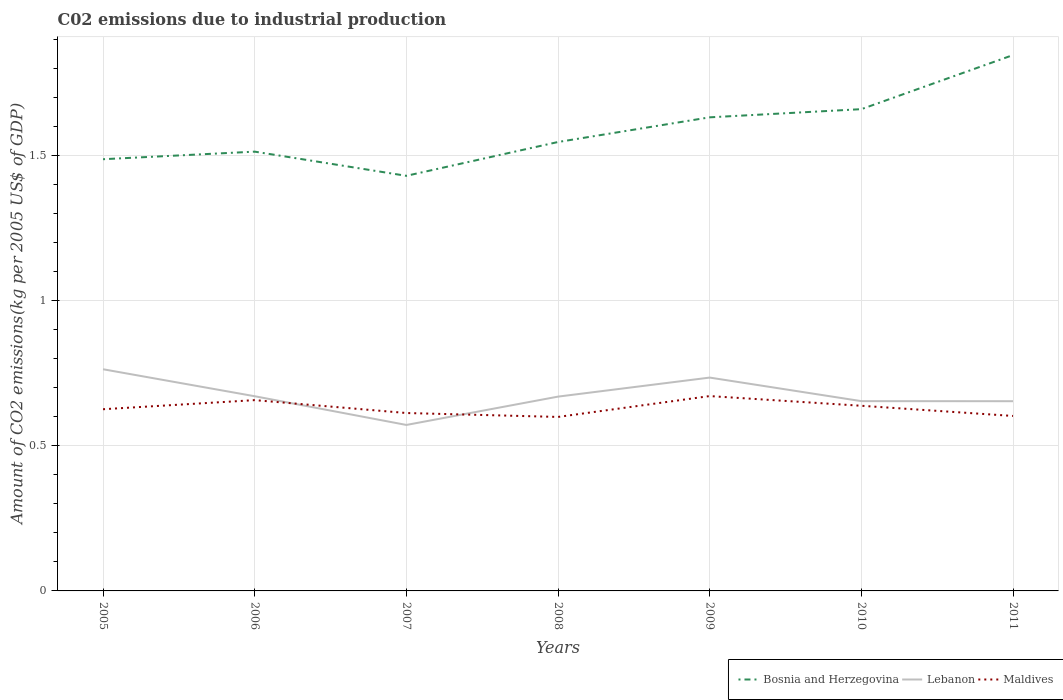Across all years, what is the maximum amount of CO2 emitted due to industrial production in Lebanon?
Give a very brief answer. 0.57. What is the total amount of CO2 emitted due to industrial production in Maldives in the graph?
Your response must be concise. 0.02. What is the difference between the highest and the second highest amount of CO2 emitted due to industrial production in Bosnia and Herzegovina?
Provide a short and direct response. 0.42. What is the difference between the highest and the lowest amount of CO2 emitted due to industrial production in Maldives?
Make the answer very short. 3. Is the amount of CO2 emitted due to industrial production in Bosnia and Herzegovina strictly greater than the amount of CO2 emitted due to industrial production in Maldives over the years?
Provide a succinct answer. No. How many lines are there?
Make the answer very short. 3. What is the difference between two consecutive major ticks on the Y-axis?
Offer a very short reply. 0.5. Are the values on the major ticks of Y-axis written in scientific E-notation?
Provide a succinct answer. No. How many legend labels are there?
Provide a succinct answer. 3. What is the title of the graph?
Your answer should be very brief. C02 emissions due to industrial production. Does "Sri Lanka" appear as one of the legend labels in the graph?
Offer a very short reply. No. What is the label or title of the Y-axis?
Offer a very short reply. Amount of CO2 emissions(kg per 2005 US$ of GDP). What is the Amount of CO2 emissions(kg per 2005 US$ of GDP) of Bosnia and Herzegovina in 2005?
Keep it short and to the point. 1.49. What is the Amount of CO2 emissions(kg per 2005 US$ of GDP) of Lebanon in 2005?
Give a very brief answer. 0.76. What is the Amount of CO2 emissions(kg per 2005 US$ of GDP) in Maldives in 2005?
Keep it short and to the point. 0.63. What is the Amount of CO2 emissions(kg per 2005 US$ of GDP) of Bosnia and Herzegovina in 2006?
Your answer should be compact. 1.51. What is the Amount of CO2 emissions(kg per 2005 US$ of GDP) of Lebanon in 2006?
Make the answer very short. 0.67. What is the Amount of CO2 emissions(kg per 2005 US$ of GDP) in Maldives in 2006?
Give a very brief answer. 0.66. What is the Amount of CO2 emissions(kg per 2005 US$ of GDP) in Bosnia and Herzegovina in 2007?
Offer a very short reply. 1.43. What is the Amount of CO2 emissions(kg per 2005 US$ of GDP) of Lebanon in 2007?
Keep it short and to the point. 0.57. What is the Amount of CO2 emissions(kg per 2005 US$ of GDP) in Maldives in 2007?
Make the answer very short. 0.61. What is the Amount of CO2 emissions(kg per 2005 US$ of GDP) in Bosnia and Herzegovina in 2008?
Give a very brief answer. 1.55. What is the Amount of CO2 emissions(kg per 2005 US$ of GDP) of Lebanon in 2008?
Give a very brief answer. 0.67. What is the Amount of CO2 emissions(kg per 2005 US$ of GDP) in Maldives in 2008?
Make the answer very short. 0.6. What is the Amount of CO2 emissions(kg per 2005 US$ of GDP) in Bosnia and Herzegovina in 2009?
Your answer should be very brief. 1.63. What is the Amount of CO2 emissions(kg per 2005 US$ of GDP) in Lebanon in 2009?
Offer a very short reply. 0.73. What is the Amount of CO2 emissions(kg per 2005 US$ of GDP) in Maldives in 2009?
Offer a very short reply. 0.67. What is the Amount of CO2 emissions(kg per 2005 US$ of GDP) in Bosnia and Herzegovina in 2010?
Make the answer very short. 1.66. What is the Amount of CO2 emissions(kg per 2005 US$ of GDP) of Lebanon in 2010?
Offer a very short reply. 0.65. What is the Amount of CO2 emissions(kg per 2005 US$ of GDP) in Maldives in 2010?
Provide a short and direct response. 0.64. What is the Amount of CO2 emissions(kg per 2005 US$ of GDP) of Bosnia and Herzegovina in 2011?
Provide a short and direct response. 1.84. What is the Amount of CO2 emissions(kg per 2005 US$ of GDP) in Lebanon in 2011?
Ensure brevity in your answer.  0.65. What is the Amount of CO2 emissions(kg per 2005 US$ of GDP) in Maldives in 2011?
Make the answer very short. 0.6. Across all years, what is the maximum Amount of CO2 emissions(kg per 2005 US$ of GDP) of Bosnia and Herzegovina?
Ensure brevity in your answer.  1.84. Across all years, what is the maximum Amount of CO2 emissions(kg per 2005 US$ of GDP) of Lebanon?
Provide a succinct answer. 0.76. Across all years, what is the maximum Amount of CO2 emissions(kg per 2005 US$ of GDP) in Maldives?
Provide a succinct answer. 0.67. Across all years, what is the minimum Amount of CO2 emissions(kg per 2005 US$ of GDP) in Bosnia and Herzegovina?
Offer a very short reply. 1.43. Across all years, what is the minimum Amount of CO2 emissions(kg per 2005 US$ of GDP) of Lebanon?
Your response must be concise. 0.57. Across all years, what is the minimum Amount of CO2 emissions(kg per 2005 US$ of GDP) in Maldives?
Your answer should be very brief. 0.6. What is the total Amount of CO2 emissions(kg per 2005 US$ of GDP) in Bosnia and Herzegovina in the graph?
Offer a terse response. 11.11. What is the total Amount of CO2 emissions(kg per 2005 US$ of GDP) in Lebanon in the graph?
Provide a succinct answer. 4.71. What is the total Amount of CO2 emissions(kg per 2005 US$ of GDP) of Maldives in the graph?
Your answer should be compact. 4.4. What is the difference between the Amount of CO2 emissions(kg per 2005 US$ of GDP) of Bosnia and Herzegovina in 2005 and that in 2006?
Provide a short and direct response. -0.03. What is the difference between the Amount of CO2 emissions(kg per 2005 US$ of GDP) in Lebanon in 2005 and that in 2006?
Ensure brevity in your answer.  0.09. What is the difference between the Amount of CO2 emissions(kg per 2005 US$ of GDP) in Maldives in 2005 and that in 2006?
Provide a succinct answer. -0.03. What is the difference between the Amount of CO2 emissions(kg per 2005 US$ of GDP) of Bosnia and Herzegovina in 2005 and that in 2007?
Make the answer very short. 0.06. What is the difference between the Amount of CO2 emissions(kg per 2005 US$ of GDP) of Lebanon in 2005 and that in 2007?
Your answer should be compact. 0.19. What is the difference between the Amount of CO2 emissions(kg per 2005 US$ of GDP) in Maldives in 2005 and that in 2007?
Make the answer very short. 0.01. What is the difference between the Amount of CO2 emissions(kg per 2005 US$ of GDP) in Bosnia and Herzegovina in 2005 and that in 2008?
Offer a very short reply. -0.06. What is the difference between the Amount of CO2 emissions(kg per 2005 US$ of GDP) in Lebanon in 2005 and that in 2008?
Ensure brevity in your answer.  0.09. What is the difference between the Amount of CO2 emissions(kg per 2005 US$ of GDP) in Maldives in 2005 and that in 2008?
Keep it short and to the point. 0.03. What is the difference between the Amount of CO2 emissions(kg per 2005 US$ of GDP) in Bosnia and Herzegovina in 2005 and that in 2009?
Keep it short and to the point. -0.14. What is the difference between the Amount of CO2 emissions(kg per 2005 US$ of GDP) of Lebanon in 2005 and that in 2009?
Ensure brevity in your answer.  0.03. What is the difference between the Amount of CO2 emissions(kg per 2005 US$ of GDP) in Maldives in 2005 and that in 2009?
Provide a succinct answer. -0.05. What is the difference between the Amount of CO2 emissions(kg per 2005 US$ of GDP) of Bosnia and Herzegovina in 2005 and that in 2010?
Your answer should be compact. -0.17. What is the difference between the Amount of CO2 emissions(kg per 2005 US$ of GDP) of Lebanon in 2005 and that in 2010?
Make the answer very short. 0.11. What is the difference between the Amount of CO2 emissions(kg per 2005 US$ of GDP) in Maldives in 2005 and that in 2010?
Provide a succinct answer. -0.01. What is the difference between the Amount of CO2 emissions(kg per 2005 US$ of GDP) in Bosnia and Herzegovina in 2005 and that in 2011?
Your answer should be compact. -0.36. What is the difference between the Amount of CO2 emissions(kg per 2005 US$ of GDP) of Lebanon in 2005 and that in 2011?
Ensure brevity in your answer.  0.11. What is the difference between the Amount of CO2 emissions(kg per 2005 US$ of GDP) of Maldives in 2005 and that in 2011?
Provide a succinct answer. 0.02. What is the difference between the Amount of CO2 emissions(kg per 2005 US$ of GDP) in Bosnia and Herzegovina in 2006 and that in 2007?
Make the answer very short. 0.08. What is the difference between the Amount of CO2 emissions(kg per 2005 US$ of GDP) of Lebanon in 2006 and that in 2007?
Your answer should be compact. 0.1. What is the difference between the Amount of CO2 emissions(kg per 2005 US$ of GDP) of Maldives in 2006 and that in 2007?
Make the answer very short. 0.04. What is the difference between the Amount of CO2 emissions(kg per 2005 US$ of GDP) in Bosnia and Herzegovina in 2006 and that in 2008?
Ensure brevity in your answer.  -0.03. What is the difference between the Amount of CO2 emissions(kg per 2005 US$ of GDP) of Lebanon in 2006 and that in 2008?
Ensure brevity in your answer.  0. What is the difference between the Amount of CO2 emissions(kg per 2005 US$ of GDP) in Maldives in 2006 and that in 2008?
Provide a succinct answer. 0.06. What is the difference between the Amount of CO2 emissions(kg per 2005 US$ of GDP) of Bosnia and Herzegovina in 2006 and that in 2009?
Ensure brevity in your answer.  -0.12. What is the difference between the Amount of CO2 emissions(kg per 2005 US$ of GDP) in Lebanon in 2006 and that in 2009?
Ensure brevity in your answer.  -0.06. What is the difference between the Amount of CO2 emissions(kg per 2005 US$ of GDP) of Maldives in 2006 and that in 2009?
Provide a succinct answer. -0.01. What is the difference between the Amount of CO2 emissions(kg per 2005 US$ of GDP) in Bosnia and Herzegovina in 2006 and that in 2010?
Provide a succinct answer. -0.15. What is the difference between the Amount of CO2 emissions(kg per 2005 US$ of GDP) in Lebanon in 2006 and that in 2010?
Offer a very short reply. 0.02. What is the difference between the Amount of CO2 emissions(kg per 2005 US$ of GDP) of Maldives in 2006 and that in 2010?
Offer a terse response. 0.02. What is the difference between the Amount of CO2 emissions(kg per 2005 US$ of GDP) of Bosnia and Herzegovina in 2006 and that in 2011?
Offer a very short reply. -0.33. What is the difference between the Amount of CO2 emissions(kg per 2005 US$ of GDP) of Lebanon in 2006 and that in 2011?
Keep it short and to the point. 0.02. What is the difference between the Amount of CO2 emissions(kg per 2005 US$ of GDP) in Maldives in 2006 and that in 2011?
Your answer should be compact. 0.05. What is the difference between the Amount of CO2 emissions(kg per 2005 US$ of GDP) of Bosnia and Herzegovina in 2007 and that in 2008?
Provide a succinct answer. -0.12. What is the difference between the Amount of CO2 emissions(kg per 2005 US$ of GDP) in Lebanon in 2007 and that in 2008?
Your answer should be compact. -0.1. What is the difference between the Amount of CO2 emissions(kg per 2005 US$ of GDP) in Maldives in 2007 and that in 2008?
Your answer should be compact. 0.01. What is the difference between the Amount of CO2 emissions(kg per 2005 US$ of GDP) of Bosnia and Herzegovina in 2007 and that in 2009?
Offer a very short reply. -0.2. What is the difference between the Amount of CO2 emissions(kg per 2005 US$ of GDP) of Lebanon in 2007 and that in 2009?
Offer a very short reply. -0.16. What is the difference between the Amount of CO2 emissions(kg per 2005 US$ of GDP) in Maldives in 2007 and that in 2009?
Ensure brevity in your answer.  -0.06. What is the difference between the Amount of CO2 emissions(kg per 2005 US$ of GDP) of Bosnia and Herzegovina in 2007 and that in 2010?
Offer a very short reply. -0.23. What is the difference between the Amount of CO2 emissions(kg per 2005 US$ of GDP) of Lebanon in 2007 and that in 2010?
Provide a short and direct response. -0.08. What is the difference between the Amount of CO2 emissions(kg per 2005 US$ of GDP) of Maldives in 2007 and that in 2010?
Your answer should be compact. -0.02. What is the difference between the Amount of CO2 emissions(kg per 2005 US$ of GDP) of Bosnia and Herzegovina in 2007 and that in 2011?
Keep it short and to the point. -0.42. What is the difference between the Amount of CO2 emissions(kg per 2005 US$ of GDP) in Lebanon in 2007 and that in 2011?
Your answer should be very brief. -0.08. What is the difference between the Amount of CO2 emissions(kg per 2005 US$ of GDP) in Maldives in 2007 and that in 2011?
Provide a succinct answer. 0.01. What is the difference between the Amount of CO2 emissions(kg per 2005 US$ of GDP) in Bosnia and Herzegovina in 2008 and that in 2009?
Your response must be concise. -0.09. What is the difference between the Amount of CO2 emissions(kg per 2005 US$ of GDP) of Lebanon in 2008 and that in 2009?
Ensure brevity in your answer.  -0.07. What is the difference between the Amount of CO2 emissions(kg per 2005 US$ of GDP) of Maldives in 2008 and that in 2009?
Make the answer very short. -0.07. What is the difference between the Amount of CO2 emissions(kg per 2005 US$ of GDP) of Bosnia and Herzegovina in 2008 and that in 2010?
Provide a short and direct response. -0.11. What is the difference between the Amount of CO2 emissions(kg per 2005 US$ of GDP) of Lebanon in 2008 and that in 2010?
Offer a terse response. 0.02. What is the difference between the Amount of CO2 emissions(kg per 2005 US$ of GDP) of Maldives in 2008 and that in 2010?
Provide a succinct answer. -0.04. What is the difference between the Amount of CO2 emissions(kg per 2005 US$ of GDP) of Bosnia and Herzegovina in 2008 and that in 2011?
Your answer should be compact. -0.3. What is the difference between the Amount of CO2 emissions(kg per 2005 US$ of GDP) of Lebanon in 2008 and that in 2011?
Offer a terse response. 0.02. What is the difference between the Amount of CO2 emissions(kg per 2005 US$ of GDP) in Maldives in 2008 and that in 2011?
Offer a very short reply. -0. What is the difference between the Amount of CO2 emissions(kg per 2005 US$ of GDP) in Bosnia and Herzegovina in 2009 and that in 2010?
Ensure brevity in your answer.  -0.03. What is the difference between the Amount of CO2 emissions(kg per 2005 US$ of GDP) of Lebanon in 2009 and that in 2010?
Keep it short and to the point. 0.08. What is the difference between the Amount of CO2 emissions(kg per 2005 US$ of GDP) in Maldives in 2009 and that in 2010?
Offer a very short reply. 0.03. What is the difference between the Amount of CO2 emissions(kg per 2005 US$ of GDP) in Bosnia and Herzegovina in 2009 and that in 2011?
Provide a short and direct response. -0.21. What is the difference between the Amount of CO2 emissions(kg per 2005 US$ of GDP) of Lebanon in 2009 and that in 2011?
Offer a very short reply. 0.08. What is the difference between the Amount of CO2 emissions(kg per 2005 US$ of GDP) of Maldives in 2009 and that in 2011?
Offer a terse response. 0.07. What is the difference between the Amount of CO2 emissions(kg per 2005 US$ of GDP) of Bosnia and Herzegovina in 2010 and that in 2011?
Your response must be concise. -0.19. What is the difference between the Amount of CO2 emissions(kg per 2005 US$ of GDP) of Lebanon in 2010 and that in 2011?
Provide a succinct answer. 0. What is the difference between the Amount of CO2 emissions(kg per 2005 US$ of GDP) of Maldives in 2010 and that in 2011?
Your answer should be very brief. 0.04. What is the difference between the Amount of CO2 emissions(kg per 2005 US$ of GDP) in Bosnia and Herzegovina in 2005 and the Amount of CO2 emissions(kg per 2005 US$ of GDP) in Lebanon in 2006?
Offer a very short reply. 0.82. What is the difference between the Amount of CO2 emissions(kg per 2005 US$ of GDP) in Bosnia and Herzegovina in 2005 and the Amount of CO2 emissions(kg per 2005 US$ of GDP) in Maldives in 2006?
Provide a succinct answer. 0.83. What is the difference between the Amount of CO2 emissions(kg per 2005 US$ of GDP) of Lebanon in 2005 and the Amount of CO2 emissions(kg per 2005 US$ of GDP) of Maldives in 2006?
Your answer should be compact. 0.11. What is the difference between the Amount of CO2 emissions(kg per 2005 US$ of GDP) of Bosnia and Herzegovina in 2005 and the Amount of CO2 emissions(kg per 2005 US$ of GDP) of Lebanon in 2007?
Ensure brevity in your answer.  0.91. What is the difference between the Amount of CO2 emissions(kg per 2005 US$ of GDP) of Bosnia and Herzegovina in 2005 and the Amount of CO2 emissions(kg per 2005 US$ of GDP) of Maldives in 2007?
Your answer should be compact. 0.87. What is the difference between the Amount of CO2 emissions(kg per 2005 US$ of GDP) of Lebanon in 2005 and the Amount of CO2 emissions(kg per 2005 US$ of GDP) of Maldives in 2007?
Offer a very short reply. 0.15. What is the difference between the Amount of CO2 emissions(kg per 2005 US$ of GDP) in Bosnia and Herzegovina in 2005 and the Amount of CO2 emissions(kg per 2005 US$ of GDP) in Lebanon in 2008?
Make the answer very short. 0.82. What is the difference between the Amount of CO2 emissions(kg per 2005 US$ of GDP) in Bosnia and Herzegovina in 2005 and the Amount of CO2 emissions(kg per 2005 US$ of GDP) in Maldives in 2008?
Provide a succinct answer. 0.89. What is the difference between the Amount of CO2 emissions(kg per 2005 US$ of GDP) in Lebanon in 2005 and the Amount of CO2 emissions(kg per 2005 US$ of GDP) in Maldives in 2008?
Keep it short and to the point. 0.16. What is the difference between the Amount of CO2 emissions(kg per 2005 US$ of GDP) of Bosnia and Herzegovina in 2005 and the Amount of CO2 emissions(kg per 2005 US$ of GDP) of Lebanon in 2009?
Provide a short and direct response. 0.75. What is the difference between the Amount of CO2 emissions(kg per 2005 US$ of GDP) of Bosnia and Herzegovina in 2005 and the Amount of CO2 emissions(kg per 2005 US$ of GDP) of Maldives in 2009?
Your answer should be very brief. 0.82. What is the difference between the Amount of CO2 emissions(kg per 2005 US$ of GDP) of Lebanon in 2005 and the Amount of CO2 emissions(kg per 2005 US$ of GDP) of Maldives in 2009?
Ensure brevity in your answer.  0.09. What is the difference between the Amount of CO2 emissions(kg per 2005 US$ of GDP) in Bosnia and Herzegovina in 2005 and the Amount of CO2 emissions(kg per 2005 US$ of GDP) in Lebanon in 2010?
Keep it short and to the point. 0.83. What is the difference between the Amount of CO2 emissions(kg per 2005 US$ of GDP) of Bosnia and Herzegovina in 2005 and the Amount of CO2 emissions(kg per 2005 US$ of GDP) of Maldives in 2010?
Your answer should be compact. 0.85. What is the difference between the Amount of CO2 emissions(kg per 2005 US$ of GDP) in Lebanon in 2005 and the Amount of CO2 emissions(kg per 2005 US$ of GDP) in Maldives in 2010?
Provide a succinct answer. 0.13. What is the difference between the Amount of CO2 emissions(kg per 2005 US$ of GDP) of Bosnia and Herzegovina in 2005 and the Amount of CO2 emissions(kg per 2005 US$ of GDP) of Lebanon in 2011?
Provide a short and direct response. 0.83. What is the difference between the Amount of CO2 emissions(kg per 2005 US$ of GDP) of Bosnia and Herzegovina in 2005 and the Amount of CO2 emissions(kg per 2005 US$ of GDP) of Maldives in 2011?
Offer a terse response. 0.88. What is the difference between the Amount of CO2 emissions(kg per 2005 US$ of GDP) of Lebanon in 2005 and the Amount of CO2 emissions(kg per 2005 US$ of GDP) of Maldives in 2011?
Offer a very short reply. 0.16. What is the difference between the Amount of CO2 emissions(kg per 2005 US$ of GDP) of Bosnia and Herzegovina in 2006 and the Amount of CO2 emissions(kg per 2005 US$ of GDP) of Lebanon in 2007?
Provide a succinct answer. 0.94. What is the difference between the Amount of CO2 emissions(kg per 2005 US$ of GDP) of Bosnia and Herzegovina in 2006 and the Amount of CO2 emissions(kg per 2005 US$ of GDP) of Maldives in 2007?
Your answer should be very brief. 0.9. What is the difference between the Amount of CO2 emissions(kg per 2005 US$ of GDP) of Lebanon in 2006 and the Amount of CO2 emissions(kg per 2005 US$ of GDP) of Maldives in 2007?
Provide a succinct answer. 0.06. What is the difference between the Amount of CO2 emissions(kg per 2005 US$ of GDP) of Bosnia and Herzegovina in 2006 and the Amount of CO2 emissions(kg per 2005 US$ of GDP) of Lebanon in 2008?
Provide a short and direct response. 0.84. What is the difference between the Amount of CO2 emissions(kg per 2005 US$ of GDP) in Bosnia and Herzegovina in 2006 and the Amount of CO2 emissions(kg per 2005 US$ of GDP) in Maldives in 2008?
Make the answer very short. 0.91. What is the difference between the Amount of CO2 emissions(kg per 2005 US$ of GDP) in Lebanon in 2006 and the Amount of CO2 emissions(kg per 2005 US$ of GDP) in Maldives in 2008?
Provide a succinct answer. 0.07. What is the difference between the Amount of CO2 emissions(kg per 2005 US$ of GDP) in Bosnia and Herzegovina in 2006 and the Amount of CO2 emissions(kg per 2005 US$ of GDP) in Maldives in 2009?
Keep it short and to the point. 0.84. What is the difference between the Amount of CO2 emissions(kg per 2005 US$ of GDP) in Lebanon in 2006 and the Amount of CO2 emissions(kg per 2005 US$ of GDP) in Maldives in 2009?
Your response must be concise. -0. What is the difference between the Amount of CO2 emissions(kg per 2005 US$ of GDP) in Bosnia and Herzegovina in 2006 and the Amount of CO2 emissions(kg per 2005 US$ of GDP) in Lebanon in 2010?
Provide a short and direct response. 0.86. What is the difference between the Amount of CO2 emissions(kg per 2005 US$ of GDP) in Bosnia and Herzegovina in 2006 and the Amount of CO2 emissions(kg per 2005 US$ of GDP) in Maldives in 2010?
Provide a short and direct response. 0.87. What is the difference between the Amount of CO2 emissions(kg per 2005 US$ of GDP) of Lebanon in 2006 and the Amount of CO2 emissions(kg per 2005 US$ of GDP) of Maldives in 2010?
Your answer should be very brief. 0.03. What is the difference between the Amount of CO2 emissions(kg per 2005 US$ of GDP) of Bosnia and Herzegovina in 2006 and the Amount of CO2 emissions(kg per 2005 US$ of GDP) of Lebanon in 2011?
Your answer should be very brief. 0.86. What is the difference between the Amount of CO2 emissions(kg per 2005 US$ of GDP) in Bosnia and Herzegovina in 2006 and the Amount of CO2 emissions(kg per 2005 US$ of GDP) in Maldives in 2011?
Ensure brevity in your answer.  0.91. What is the difference between the Amount of CO2 emissions(kg per 2005 US$ of GDP) of Lebanon in 2006 and the Amount of CO2 emissions(kg per 2005 US$ of GDP) of Maldives in 2011?
Offer a terse response. 0.07. What is the difference between the Amount of CO2 emissions(kg per 2005 US$ of GDP) in Bosnia and Herzegovina in 2007 and the Amount of CO2 emissions(kg per 2005 US$ of GDP) in Lebanon in 2008?
Keep it short and to the point. 0.76. What is the difference between the Amount of CO2 emissions(kg per 2005 US$ of GDP) of Bosnia and Herzegovina in 2007 and the Amount of CO2 emissions(kg per 2005 US$ of GDP) of Maldives in 2008?
Ensure brevity in your answer.  0.83. What is the difference between the Amount of CO2 emissions(kg per 2005 US$ of GDP) in Lebanon in 2007 and the Amount of CO2 emissions(kg per 2005 US$ of GDP) in Maldives in 2008?
Keep it short and to the point. -0.03. What is the difference between the Amount of CO2 emissions(kg per 2005 US$ of GDP) of Bosnia and Herzegovina in 2007 and the Amount of CO2 emissions(kg per 2005 US$ of GDP) of Lebanon in 2009?
Offer a terse response. 0.69. What is the difference between the Amount of CO2 emissions(kg per 2005 US$ of GDP) of Bosnia and Herzegovina in 2007 and the Amount of CO2 emissions(kg per 2005 US$ of GDP) of Maldives in 2009?
Ensure brevity in your answer.  0.76. What is the difference between the Amount of CO2 emissions(kg per 2005 US$ of GDP) in Lebanon in 2007 and the Amount of CO2 emissions(kg per 2005 US$ of GDP) in Maldives in 2009?
Your answer should be very brief. -0.1. What is the difference between the Amount of CO2 emissions(kg per 2005 US$ of GDP) in Bosnia and Herzegovina in 2007 and the Amount of CO2 emissions(kg per 2005 US$ of GDP) in Lebanon in 2010?
Ensure brevity in your answer.  0.78. What is the difference between the Amount of CO2 emissions(kg per 2005 US$ of GDP) of Bosnia and Herzegovina in 2007 and the Amount of CO2 emissions(kg per 2005 US$ of GDP) of Maldives in 2010?
Ensure brevity in your answer.  0.79. What is the difference between the Amount of CO2 emissions(kg per 2005 US$ of GDP) in Lebanon in 2007 and the Amount of CO2 emissions(kg per 2005 US$ of GDP) in Maldives in 2010?
Offer a very short reply. -0.07. What is the difference between the Amount of CO2 emissions(kg per 2005 US$ of GDP) of Bosnia and Herzegovina in 2007 and the Amount of CO2 emissions(kg per 2005 US$ of GDP) of Lebanon in 2011?
Keep it short and to the point. 0.78. What is the difference between the Amount of CO2 emissions(kg per 2005 US$ of GDP) of Bosnia and Herzegovina in 2007 and the Amount of CO2 emissions(kg per 2005 US$ of GDP) of Maldives in 2011?
Ensure brevity in your answer.  0.83. What is the difference between the Amount of CO2 emissions(kg per 2005 US$ of GDP) of Lebanon in 2007 and the Amount of CO2 emissions(kg per 2005 US$ of GDP) of Maldives in 2011?
Your answer should be compact. -0.03. What is the difference between the Amount of CO2 emissions(kg per 2005 US$ of GDP) of Bosnia and Herzegovina in 2008 and the Amount of CO2 emissions(kg per 2005 US$ of GDP) of Lebanon in 2009?
Your answer should be compact. 0.81. What is the difference between the Amount of CO2 emissions(kg per 2005 US$ of GDP) of Bosnia and Herzegovina in 2008 and the Amount of CO2 emissions(kg per 2005 US$ of GDP) of Maldives in 2009?
Provide a succinct answer. 0.87. What is the difference between the Amount of CO2 emissions(kg per 2005 US$ of GDP) in Lebanon in 2008 and the Amount of CO2 emissions(kg per 2005 US$ of GDP) in Maldives in 2009?
Your answer should be very brief. -0. What is the difference between the Amount of CO2 emissions(kg per 2005 US$ of GDP) of Bosnia and Herzegovina in 2008 and the Amount of CO2 emissions(kg per 2005 US$ of GDP) of Lebanon in 2010?
Your answer should be very brief. 0.89. What is the difference between the Amount of CO2 emissions(kg per 2005 US$ of GDP) of Bosnia and Herzegovina in 2008 and the Amount of CO2 emissions(kg per 2005 US$ of GDP) of Maldives in 2010?
Offer a very short reply. 0.91. What is the difference between the Amount of CO2 emissions(kg per 2005 US$ of GDP) of Lebanon in 2008 and the Amount of CO2 emissions(kg per 2005 US$ of GDP) of Maldives in 2010?
Provide a succinct answer. 0.03. What is the difference between the Amount of CO2 emissions(kg per 2005 US$ of GDP) of Bosnia and Herzegovina in 2008 and the Amount of CO2 emissions(kg per 2005 US$ of GDP) of Lebanon in 2011?
Ensure brevity in your answer.  0.89. What is the difference between the Amount of CO2 emissions(kg per 2005 US$ of GDP) of Bosnia and Herzegovina in 2008 and the Amount of CO2 emissions(kg per 2005 US$ of GDP) of Maldives in 2011?
Give a very brief answer. 0.94. What is the difference between the Amount of CO2 emissions(kg per 2005 US$ of GDP) in Lebanon in 2008 and the Amount of CO2 emissions(kg per 2005 US$ of GDP) in Maldives in 2011?
Make the answer very short. 0.07. What is the difference between the Amount of CO2 emissions(kg per 2005 US$ of GDP) in Bosnia and Herzegovina in 2009 and the Amount of CO2 emissions(kg per 2005 US$ of GDP) in Lebanon in 2010?
Provide a short and direct response. 0.98. What is the difference between the Amount of CO2 emissions(kg per 2005 US$ of GDP) of Lebanon in 2009 and the Amount of CO2 emissions(kg per 2005 US$ of GDP) of Maldives in 2010?
Make the answer very short. 0.1. What is the difference between the Amount of CO2 emissions(kg per 2005 US$ of GDP) of Bosnia and Herzegovina in 2009 and the Amount of CO2 emissions(kg per 2005 US$ of GDP) of Lebanon in 2011?
Keep it short and to the point. 0.98. What is the difference between the Amount of CO2 emissions(kg per 2005 US$ of GDP) of Bosnia and Herzegovina in 2009 and the Amount of CO2 emissions(kg per 2005 US$ of GDP) of Maldives in 2011?
Keep it short and to the point. 1.03. What is the difference between the Amount of CO2 emissions(kg per 2005 US$ of GDP) in Lebanon in 2009 and the Amount of CO2 emissions(kg per 2005 US$ of GDP) in Maldives in 2011?
Give a very brief answer. 0.13. What is the difference between the Amount of CO2 emissions(kg per 2005 US$ of GDP) of Bosnia and Herzegovina in 2010 and the Amount of CO2 emissions(kg per 2005 US$ of GDP) of Lebanon in 2011?
Your answer should be very brief. 1.01. What is the difference between the Amount of CO2 emissions(kg per 2005 US$ of GDP) of Bosnia and Herzegovina in 2010 and the Amount of CO2 emissions(kg per 2005 US$ of GDP) of Maldives in 2011?
Ensure brevity in your answer.  1.06. What is the difference between the Amount of CO2 emissions(kg per 2005 US$ of GDP) in Lebanon in 2010 and the Amount of CO2 emissions(kg per 2005 US$ of GDP) in Maldives in 2011?
Your answer should be very brief. 0.05. What is the average Amount of CO2 emissions(kg per 2005 US$ of GDP) in Bosnia and Herzegovina per year?
Keep it short and to the point. 1.59. What is the average Amount of CO2 emissions(kg per 2005 US$ of GDP) of Lebanon per year?
Make the answer very short. 0.67. What is the average Amount of CO2 emissions(kg per 2005 US$ of GDP) in Maldives per year?
Offer a terse response. 0.63. In the year 2005, what is the difference between the Amount of CO2 emissions(kg per 2005 US$ of GDP) in Bosnia and Herzegovina and Amount of CO2 emissions(kg per 2005 US$ of GDP) in Lebanon?
Give a very brief answer. 0.72. In the year 2005, what is the difference between the Amount of CO2 emissions(kg per 2005 US$ of GDP) in Bosnia and Herzegovina and Amount of CO2 emissions(kg per 2005 US$ of GDP) in Maldives?
Your answer should be compact. 0.86. In the year 2005, what is the difference between the Amount of CO2 emissions(kg per 2005 US$ of GDP) of Lebanon and Amount of CO2 emissions(kg per 2005 US$ of GDP) of Maldives?
Provide a short and direct response. 0.14. In the year 2006, what is the difference between the Amount of CO2 emissions(kg per 2005 US$ of GDP) in Bosnia and Herzegovina and Amount of CO2 emissions(kg per 2005 US$ of GDP) in Lebanon?
Your answer should be compact. 0.84. In the year 2006, what is the difference between the Amount of CO2 emissions(kg per 2005 US$ of GDP) in Bosnia and Herzegovina and Amount of CO2 emissions(kg per 2005 US$ of GDP) in Maldives?
Offer a terse response. 0.86. In the year 2006, what is the difference between the Amount of CO2 emissions(kg per 2005 US$ of GDP) in Lebanon and Amount of CO2 emissions(kg per 2005 US$ of GDP) in Maldives?
Give a very brief answer. 0.01. In the year 2007, what is the difference between the Amount of CO2 emissions(kg per 2005 US$ of GDP) of Bosnia and Herzegovina and Amount of CO2 emissions(kg per 2005 US$ of GDP) of Lebanon?
Ensure brevity in your answer.  0.86. In the year 2007, what is the difference between the Amount of CO2 emissions(kg per 2005 US$ of GDP) in Bosnia and Herzegovina and Amount of CO2 emissions(kg per 2005 US$ of GDP) in Maldives?
Provide a short and direct response. 0.82. In the year 2007, what is the difference between the Amount of CO2 emissions(kg per 2005 US$ of GDP) in Lebanon and Amount of CO2 emissions(kg per 2005 US$ of GDP) in Maldives?
Provide a short and direct response. -0.04. In the year 2008, what is the difference between the Amount of CO2 emissions(kg per 2005 US$ of GDP) of Bosnia and Herzegovina and Amount of CO2 emissions(kg per 2005 US$ of GDP) of Lebanon?
Your response must be concise. 0.88. In the year 2008, what is the difference between the Amount of CO2 emissions(kg per 2005 US$ of GDP) of Bosnia and Herzegovina and Amount of CO2 emissions(kg per 2005 US$ of GDP) of Maldives?
Give a very brief answer. 0.95. In the year 2008, what is the difference between the Amount of CO2 emissions(kg per 2005 US$ of GDP) of Lebanon and Amount of CO2 emissions(kg per 2005 US$ of GDP) of Maldives?
Provide a short and direct response. 0.07. In the year 2009, what is the difference between the Amount of CO2 emissions(kg per 2005 US$ of GDP) of Bosnia and Herzegovina and Amount of CO2 emissions(kg per 2005 US$ of GDP) of Lebanon?
Your answer should be very brief. 0.9. In the year 2009, what is the difference between the Amount of CO2 emissions(kg per 2005 US$ of GDP) in Bosnia and Herzegovina and Amount of CO2 emissions(kg per 2005 US$ of GDP) in Maldives?
Make the answer very short. 0.96. In the year 2009, what is the difference between the Amount of CO2 emissions(kg per 2005 US$ of GDP) of Lebanon and Amount of CO2 emissions(kg per 2005 US$ of GDP) of Maldives?
Offer a terse response. 0.06. In the year 2010, what is the difference between the Amount of CO2 emissions(kg per 2005 US$ of GDP) in Bosnia and Herzegovina and Amount of CO2 emissions(kg per 2005 US$ of GDP) in Lebanon?
Your response must be concise. 1.01. In the year 2010, what is the difference between the Amount of CO2 emissions(kg per 2005 US$ of GDP) of Bosnia and Herzegovina and Amount of CO2 emissions(kg per 2005 US$ of GDP) of Maldives?
Offer a very short reply. 1.02. In the year 2010, what is the difference between the Amount of CO2 emissions(kg per 2005 US$ of GDP) of Lebanon and Amount of CO2 emissions(kg per 2005 US$ of GDP) of Maldives?
Keep it short and to the point. 0.02. In the year 2011, what is the difference between the Amount of CO2 emissions(kg per 2005 US$ of GDP) in Bosnia and Herzegovina and Amount of CO2 emissions(kg per 2005 US$ of GDP) in Lebanon?
Give a very brief answer. 1.19. In the year 2011, what is the difference between the Amount of CO2 emissions(kg per 2005 US$ of GDP) in Bosnia and Herzegovina and Amount of CO2 emissions(kg per 2005 US$ of GDP) in Maldives?
Ensure brevity in your answer.  1.24. In the year 2011, what is the difference between the Amount of CO2 emissions(kg per 2005 US$ of GDP) in Lebanon and Amount of CO2 emissions(kg per 2005 US$ of GDP) in Maldives?
Keep it short and to the point. 0.05. What is the ratio of the Amount of CO2 emissions(kg per 2005 US$ of GDP) of Bosnia and Herzegovina in 2005 to that in 2006?
Keep it short and to the point. 0.98. What is the ratio of the Amount of CO2 emissions(kg per 2005 US$ of GDP) of Lebanon in 2005 to that in 2006?
Keep it short and to the point. 1.14. What is the ratio of the Amount of CO2 emissions(kg per 2005 US$ of GDP) of Maldives in 2005 to that in 2006?
Give a very brief answer. 0.95. What is the ratio of the Amount of CO2 emissions(kg per 2005 US$ of GDP) in Bosnia and Herzegovina in 2005 to that in 2007?
Provide a succinct answer. 1.04. What is the ratio of the Amount of CO2 emissions(kg per 2005 US$ of GDP) of Lebanon in 2005 to that in 2007?
Provide a succinct answer. 1.34. What is the ratio of the Amount of CO2 emissions(kg per 2005 US$ of GDP) in Maldives in 2005 to that in 2007?
Provide a short and direct response. 1.02. What is the ratio of the Amount of CO2 emissions(kg per 2005 US$ of GDP) of Bosnia and Herzegovina in 2005 to that in 2008?
Ensure brevity in your answer.  0.96. What is the ratio of the Amount of CO2 emissions(kg per 2005 US$ of GDP) in Lebanon in 2005 to that in 2008?
Provide a short and direct response. 1.14. What is the ratio of the Amount of CO2 emissions(kg per 2005 US$ of GDP) in Maldives in 2005 to that in 2008?
Offer a terse response. 1.04. What is the ratio of the Amount of CO2 emissions(kg per 2005 US$ of GDP) of Bosnia and Herzegovina in 2005 to that in 2009?
Provide a succinct answer. 0.91. What is the ratio of the Amount of CO2 emissions(kg per 2005 US$ of GDP) in Lebanon in 2005 to that in 2009?
Your answer should be compact. 1.04. What is the ratio of the Amount of CO2 emissions(kg per 2005 US$ of GDP) of Maldives in 2005 to that in 2009?
Provide a succinct answer. 0.93. What is the ratio of the Amount of CO2 emissions(kg per 2005 US$ of GDP) in Bosnia and Herzegovina in 2005 to that in 2010?
Make the answer very short. 0.9. What is the ratio of the Amount of CO2 emissions(kg per 2005 US$ of GDP) in Lebanon in 2005 to that in 2010?
Make the answer very short. 1.17. What is the ratio of the Amount of CO2 emissions(kg per 2005 US$ of GDP) in Maldives in 2005 to that in 2010?
Your response must be concise. 0.98. What is the ratio of the Amount of CO2 emissions(kg per 2005 US$ of GDP) of Bosnia and Herzegovina in 2005 to that in 2011?
Your answer should be compact. 0.81. What is the ratio of the Amount of CO2 emissions(kg per 2005 US$ of GDP) in Lebanon in 2005 to that in 2011?
Your answer should be very brief. 1.17. What is the ratio of the Amount of CO2 emissions(kg per 2005 US$ of GDP) of Maldives in 2005 to that in 2011?
Provide a succinct answer. 1.04. What is the ratio of the Amount of CO2 emissions(kg per 2005 US$ of GDP) of Bosnia and Herzegovina in 2006 to that in 2007?
Provide a short and direct response. 1.06. What is the ratio of the Amount of CO2 emissions(kg per 2005 US$ of GDP) in Lebanon in 2006 to that in 2007?
Your response must be concise. 1.17. What is the ratio of the Amount of CO2 emissions(kg per 2005 US$ of GDP) in Maldives in 2006 to that in 2007?
Ensure brevity in your answer.  1.07. What is the ratio of the Amount of CO2 emissions(kg per 2005 US$ of GDP) of Bosnia and Herzegovina in 2006 to that in 2008?
Your answer should be very brief. 0.98. What is the ratio of the Amount of CO2 emissions(kg per 2005 US$ of GDP) in Maldives in 2006 to that in 2008?
Your answer should be very brief. 1.1. What is the ratio of the Amount of CO2 emissions(kg per 2005 US$ of GDP) in Bosnia and Herzegovina in 2006 to that in 2009?
Offer a very short reply. 0.93. What is the ratio of the Amount of CO2 emissions(kg per 2005 US$ of GDP) of Lebanon in 2006 to that in 2009?
Make the answer very short. 0.91. What is the ratio of the Amount of CO2 emissions(kg per 2005 US$ of GDP) of Maldives in 2006 to that in 2009?
Offer a very short reply. 0.98. What is the ratio of the Amount of CO2 emissions(kg per 2005 US$ of GDP) in Bosnia and Herzegovina in 2006 to that in 2010?
Provide a short and direct response. 0.91. What is the ratio of the Amount of CO2 emissions(kg per 2005 US$ of GDP) in Lebanon in 2006 to that in 2010?
Your answer should be compact. 1.03. What is the ratio of the Amount of CO2 emissions(kg per 2005 US$ of GDP) in Maldives in 2006 to that in 2010?
Make the answer very short. 1.03. What is the ratio of the Amount of CO2 emissions(kg per 2005 US$ of GDP) in Bosnia and Herzegovina in 2006 to that in 2011?
Keep it short and to the point. 0.82. What is the ratio of the Amount of CO2 emissions(kg per 2005 US$ of GDP) in Lebanon in 2006 to that in 2011?
Give a very brief answer. 1.03. What is the ratio of the Amount of CO2 emissions(kg per 2005 US$ of GDP) in Maldives in 2006 to that in 2011?
Provide a short and direct response. 1.09. What is the ratio of the Amount of CO2 emissions(kg per 2005 US$ of GDP) of Bosnia and Herzegovina in 2007 to that in 2008?
Provide a succinct answer. 0.92. What is the ratio of the Amount of CO2 emissions(kg per 2005 US$ of GDP) in Lebanon in 2007 to that in 2008?
Make the answer very short. 0.85. What is the ratio of the Amount of CO2 emissions(kg per 2005 US$ of GDP) of Maldives in 2007 to that in 2008?
Keep it short and to the point. 1.02. What is the ratio of the Amount of CO2 emissions(kg per 2005 US$ of GDP) in Bosnia and Herzegovina in 2007 to that in 2009?
Your response must be concise. 0.88. What is the ratio of the Amount of CO2 emissions(kg per 2005 US$ of GDP) in Lebanon in 2007 to that in 2009?
Your answer should be very brief. 0.78. What is the ratio of the Amount of CO2 emissions(kg per 2005 US$ of GDP) in Bosnia and Herzegovina in 2007 to that in 2010?
Your answer should be very brief. 0.86. What is the ratio of the Amount of CO2 emissions(kg per 2005 US$ of GDP) in Lebanon in 2007 to that in 2010?
Your response must be concise. 0.87. What is the ratio of the Amount of CO2 emissions(kg per 2005 US$ of GDP) in Maldives in 2007 to that in 2010?
Give a very brief answer. 0.96. What is the ratio of the Amount of CO2 emissions(kg per 2005 US$ of GDP) in Bosnia and Herzegovina in 2007 to that in 2011?
Provide a succinct answer. 0.77. What is the ratio of the Amount of CO2 emissions(kg per 2005 US$ of GDP) of Lebanon in 2007 to that in 2011?
Ensure brevity in your answer.  0.87. What is the ratio of the Amount of CO2 emissions(kg per 2005 US$ of GDP) of Maldives in 2007 to that in 2011?
Your answer should be very brief. 1.02. What is the ratio of the Amount of CO2 emissions(kg per 2005 US$ of GDP) in Bosnia and Herzegovina in 2008 to that in 2009?
Make the answer very short. 0.95. What is the ratio of the Amount of CO2 emissions(kg per 2005 US$ of GDP) of Lebanon in 2008 to that in 2009?
Give a very brief answer. 0.91. What is the ratio of the Amount of CO2 emissions(kg per 2005 US$ of GDP) of Maldives in 2008 to that in 2009?
Give a very brief answer. 0.89. What is the ratio of the Amount of CO2 emissions(kg per 2005 US$ of GDP) in Bosnia and Herzegovina in 2008 to that in 2010?
Give a very brief answer. 0.93. What is the ratio of the Amount of CO2 emissions(kg per 2005 US$ of GDP) in Lebanon in 2008 to that in 2010?
Your answer should be compact. 1.02. What is the ratio of the Amount of CO2 emissions(kg per 2005 US$ of GDP) of Maldives in 2008 to that in 2010?
Ensure brevity in your answer.  0.94. What is the ratio of the Amount of CO2 emissions(kg per 2005 US$ of GDP) of Bosnia and Herzegovina in 2008 to that in 2011?
Ensure brevity in your answer.  0.84. What is the ratio of the Amount of CO2 emissions(kg per 2005 US$ of GDP) in Lebanon in 2008 to that in 2011?
Your answer should be compact. 1.02. What is the ratio of the Amount of CO2 emissions(kg per 2005 US$ of GDP) of Maldives in 2008 to that in 2011?
Offer a very short reply. 0.99. What is the ratio of the Amount of CO2 emissions(kg per 2005 US$ of GDP) of Bosnia and Herzegovina in 2009 to that in 2010?
Your answer should be compact. 0.98. What is the ratio of the Amount of CO2 emissions(kg per 2005 US$ of GDP) in Lebanon in 2009 to that in 2010?
Provide a short and direct response. 1.12. What is the ratio of the Amount of CO2 emissions(kg per 2005 US$ of GDP) in Maldives in 2009 to that in 2010?
Provide a short and direct response. 1.05. What is the ratio of the Amount of CO2 emissions(kg per 2005 US$ of GDP) of Bosnia and Herzegovina in 2009 to that in 2011?
Your answer should be compact. 0.88. What is the ratio of the Amount of CO2 emissions(kg per 2005 US$ of GDP) of Lebanon in 2009 to that in 2011?
Offer a very short reply. 1.12. What is the ratio of the Amount of CO2 emissions(kg per 2005 US$ of GDP) in Maldives in 2009 to that in 2011?
Your answer should be very brief. 1.11. What is the ratio of the Amount of CO2 emissions(kg per 2005 US$ of GDP) in Bosnia and Herzegovina in 2010 to that in 2011?
Ensure brevity in your answer.  0.9. What is the ratio of the Amount of CO2 emissions(kg per 2005 US$ of GDP) of Maldives in 2010 to that in 2011?
Your answer should be compact. 1.06. What is the difference between the highest and the second highest Amount of CO2 emissions(kg per 2005 US$ of GDP) of Bosnia and Herzegovina?
Keep it short and to the point. 0.19. What is the difference between the highest and the second highest Amount of CO2 emissions(kg per 2005 US$ of GDP) in Lebanon?
Give a very brief answer. 0.03. What is the difference between the highest and the second highest Amount of CO2 emissions(kg per 2005 US$ of GDP) of Maldives?
Provide a short and direct response. 0.01. What is the difference between the highest and the lowest Amount of CO2 emissions(kg per 2005 US$ of GDP) of Bosnia and Herzegovina?
Offer a terse response. 0.42. What is the difference between the highest and the lowest Amount of CO2 emissions(kg per 2005 US$ of GDP) of Lebanon?
Provide a short and direct response. 0.19. What is the difference between the highest and the lowest Amount of CO2 emissions(kg per 2005 US$ of GDP) in Maldives?
Ensure brevity in your answer.  0.07. 